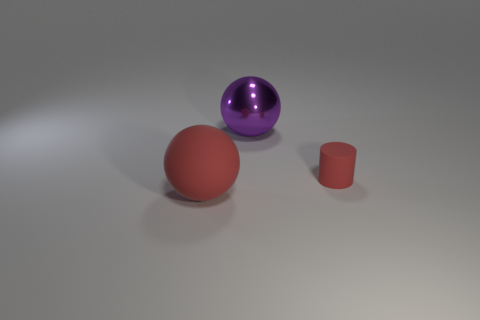Is there any other thing that is the same shape as the small thing?
Provide a short and direct response. No. Is there any other thing that is the same size as the rubber cylinder?
Make the answer very short. No. Is there anything else that is made of the same material as the large purple thing?
Your answer should be very brief. No. What is the color of the ball that is behind the matte cylinder?
Make the answer very short. Purple. There is a big ball that is on the right side of the red matte object on the left side of the tiny rubber thing; how many red cylinders are in front of it?
Keep it short and to the point. 1. What number of matte objects are to the right of the sphere right of the red sphere?
Provide a succinct answer. 1. How many big red rubber things are left of the shiny ball?
Your response must be concise. 1. How many other objects are the same size as the purple thing?
Your answer should be compact. 1. There is another shiny thing that is the same shape as the big red object; what size is it?
Give a very brief answer. Large. The red rubber object that is on the left side of the large purple metal ball has what shape?
Make the answer very short. Sphere. 